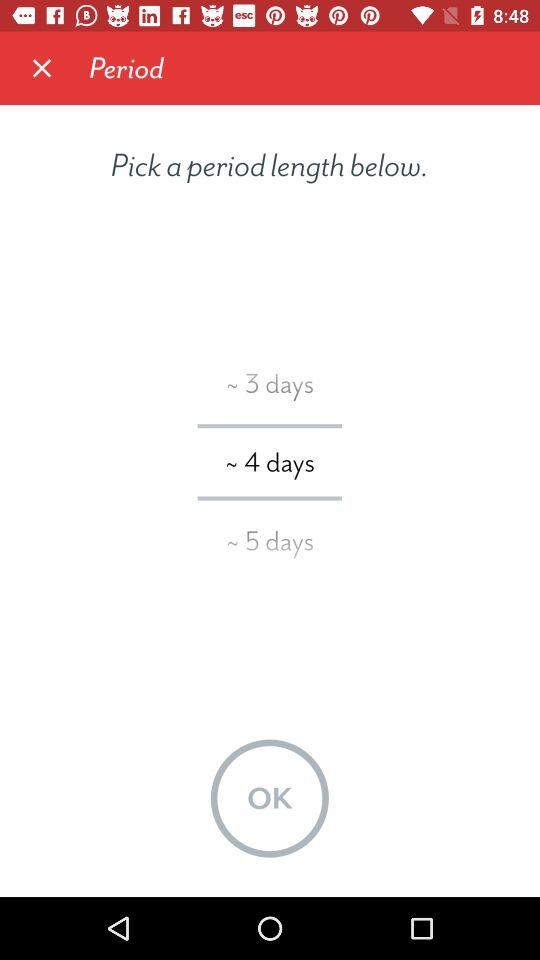What's the selected period length? The selected period length is "~ 4 days". 